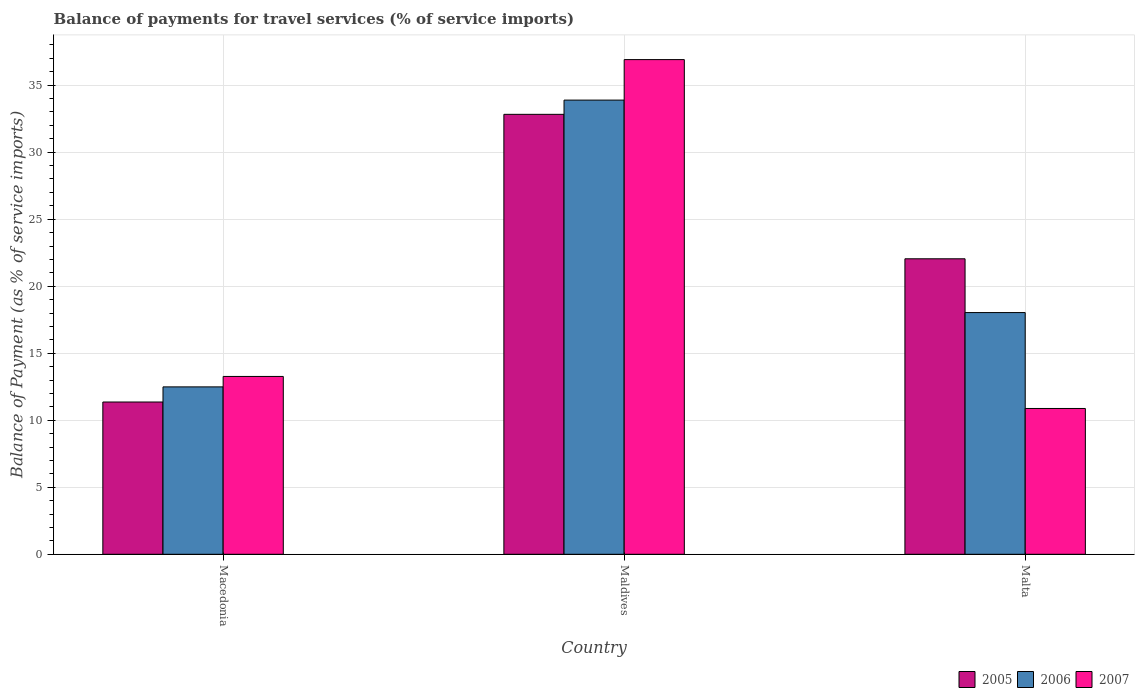How many different coloured bars are there?
Offer a very short reply. 3. How many bars are there on the 3rd tick from the right?
Make the answer very short. 3. What is the label of the 3rd group of bars from the left?
Offer a terse response. Malta. In how many cases, is the number of bars for a given country not equal to the number of legend labels?
Keep it short and to the point. 0. What is the balance of payments for travel services in 2007 in Maldives?
Offer a terse response. 36.91. Across all countries, what is the maximum balance of payments for travel services in 2005?
Ensure brevity in your answer.  32.82. Across all countries, what is the minimum balance of payments for travel services in 2005?
Your response must be concise. 11.36. In which country was the balance of payments for travel services in 2005 maximum?
Make the answer very short. Maldives. In which country was the balance of payments for travel services in 2005 minimum?
Ensure brevity in your answer.  Macedonia. What is the total balance of payments for travel services in 2006 in the graph?
Your response must be concise. 64.41. What is the difference between the balance of payments for travel services in 2005 in Macedonia and that in Malta?
Ensure brevity in your answer.  -10.68. What is the difference between the balance of payments for travel services in 2005 in Macedonia and the balance of payments for travel services in 2007 in Maldives?
Keep it short and to the point. -25.55. What is the average balance of payments for travel services in 2005 per country?
Your response must be concise. 22.08. What is the difference between the balance of payments for travel services of/in 2007 and balance of payments for travel services of/in 2006 in Malta?
Provide a short and direct response. -7.16. What is the ratio of the balance of payments for travel services in 2005 in Macedonia to that in Malta?
Offer a terse response. 0.52. Is the difference between the balance of payments for travel services in 2007 in Macedonia and Maldives greater than the difference between the balance of payments for travel services in 2006 in Macedonia and Maldives?
Keep it short and to the point. No. What is the difference between the highest and the second highest balance of payments for travel services in 2006?
Give a very brief answer. 15.85. What is the difference between the highest and the lowest balance of payments for travel services in 2006?
Offer a terse response. 21.4. In how many countries, is the balance of payments for travel services in 2006 greater than the average balance of payments for travel services in 2006 taken over all countries?
Keep it short and to the point. 1. Is it the case that in every country, the sum of the balance of payments for travel services in 2005 and balance of payments for travel services in 2007 is greater than the balance of payments for travel services in 2006?
Your answer should be compact. Yes. How many bars are there?
Keep it short and to the point. 9. How many countries are there in the graph?
Provide a succinct answer. 3. Are the values on the major ticks of Y-axis written in scientific E-notation?
Offer a terse response. No. What is the title of the graph?
Ensure brevity in your answer.  Balance of payments for travel services (% of service imports). Does "2011" appear as one of the legend labels in the graph?
Provide a succinct answer. No. What is the label or title of the Y-axis?
Your answer should be very brief. Balance of Payment (as % of service imports). What is the Balance of Payment (as % of service imports) of 2005 in Macedonia?
Your answer should be very brief. 11.36. What is the Balance of Payment (as % of service imports) in 2006 in Macedonia?
Your response must be concise. 12.49. What is the Balance of Payment (as % of service imports) of 2007 in Macedonia?
Give a very brief answer. 13.27. What is the Balance of Payment (as % of service imports) in 2005 in Maldives?
Your response must be concise. 32.82. What is the Balance of Payment (as % of service imports) of 2006 in Maldives?
Provide a succinct answer. 33.89. What is the Balance of Payment (as % of service imports) of 2007 in Maldives?
Provide a succinct answer. 36.91. What is the Balance of Payment (as % of service imports) in 2005 in Malta?
Provide a succinct answer. 22.05. What is the Balance of Payment (as % of service imports) in 2006 in Malta?
Offer a terse response. 18.03. What is the Balance of Payment (as % of service imports) of 2007 in Malta?
Your answer should be very brief. 10.88. Across all countries, what is the maximum Balance of Payment (as % of service imports) of 2005?
Make the answer very short. 32.82. Across all countries, what is the maximum Balance of Payment (as % of service imports) in 2006?
Keep it short and to the point. 33.89. Across all countries, what is the maximum Balance of Payment (as % of service imports) of 2007?
Your response must be concise. 36.91. Across all countries, what is the minimum Balance of Payment (as % of service imports) of 2005?
Ensure brevity in your answer.  11.36. Across all countries, what is the minimum Balance of Payment (as % of service imports) of 2006?
Your answer should be very brief. 12.49. Across all countries, what is the minimum Balance of Payment (as % of service imports) of 2007?
Offer a terse response. 10.88. What is the total Balance of Payment (as % of service imports) of 2005 in the graph?
Provide a succinct answer. 66.23. What is the total Balance of Payment (as % of service imports) of 2006 in the graph?
Make the answer very short. 64.41. What is the total Balance of Payment (as % of service imports) of 2007 in the graph?
Keep it short and to the point. 61.05. What is the difference between the Balance of Payment (as % of service imports) in 2005 in Macedonia and that in Maldives?
Offer a terse response. -21.46. What is the difference between the Balance of Payment (as % of service imports) of 2006 in Macedonia and that in Maldives?
Keep it short and to the point. -21.4. What is the difference between the Balance of Payment (as % of service imports) of 2007 in Macedonia and that in Maldives?
Your answer should be compact. -23.64. What is the difference between the Balance of Payment (as % of service imports) in 2005 in Macedonia and that in Malta?
Ensure brevity in your answer.  -10.68. What is the difference between the Balance of Payment (as % of service imports) of 2006 in Macedonia and that in Malta?
Give a very brief answer. -5.54. What is the difference between the Balance of Payment (as % of service imports) of 2007 in Macedonia and that in Malta?
Offer a very short reply. 2.39. What is the difference between the Balance of Payment (as % of service imports) in 2005 in Maldives and that in Malta?
Offer a very short reply. 10.78. What is the difference between the Balance of Payment (as % of service imports) in 2006 in Maldives and that in Malta?
Your answer should be compact. 15.85. What is the difference between the Balance of Payment (as % of service imports) of 2007 in Maldives and that in Malta?
Your response must be concise. 26.03. What is the difference between the Balance of Payment (as % of service imports) in 2005 in Macedonia and the Balance of Payment (as % of service imports) in 2006 in Maldives?
Provide a succinct answer. -22.52. What is the difference between the Balance of Payment (as % of service imports) in 2005 in Macedonia and the Balance of Payment (as % of service imports) in 2007 in Maldives?
Give a very brief answer. -25.55. What is the difference between the Balance of Payment (as % of service imports) of 2006 in Macedonia and the Balance of Payment (as % of service imports) of 2007 in Maldives?
Keep it short and to the point. -24.42. What is the difference between the Balance of Payment (as % of service imports) in 2005 in Macedonia and the Balance of Payment (as % of service imports) in 2006 in Malta?
Your response must be concise. -6.67. What is the difference between the Balance of Payment (as % of service imports) of 2005 in Macedonia and the Balance of Payment (as % of service imports) of 2007 in Malta?
Ensure brevity in your answer.  0.48. What is the difference between the Balance of Payment (as % of service imports) in 2006 in Macedonia and the Balance of Payment (as % of service imports) in 2007 in Malta?
Keep it short and to the point. 1.61. What is the difference between the Balance of Payment (as % of service imports) of 2005 in Maldives and the Balance of Payment (as % of service imports) of 2006 in Malta?
Offer a very short reply. 14.79. What is the difference between the Balance of Payment (as % of service imports) in 2005 in Maldives and the Balance of Payment (as % of service imports) in 2007 in Malta?
Provide a succinct answer. 21.95. What is the difference between the Balance of Payment (as % of service imports) in 2006 in Maldives and the Balance of Payment (as % of service imports) in 2007 in Malta?
Provide a succinct answer. 23.01. What is the average Balance of Payment (as % of service imports) of 2005 per country?
Make the answer very short. 22.08. What is the average Balance of Payment (as % of service imports) in 2006 per country?
Give a very brief answer. 21.47. What is the average Balance of Payment (as % of service imports) in 2007 per country?
Provide a short and direct response. 20.35. What is the difference between the Balance of Payment (as % of service imports) in 2005 and Balance of Payment (as % of service imports) in 2006 in Macedonia?
Your answer should be compact. -1.13. What is the difference between the Balance of Payment (as % of service imports) in 2005 and Balance of Payment (as % of service imports) in 2007 in Macedonia?
Give a very brief answer. -1.91. What is the difference between the Balance of Payment (as % of service imports) of 2006 and Balance of Payment (as % of service imports) of 2007 in Macedonia?
Provide a short and direct response. -0.78. What is the difference between the Balance of Payment (as % of service imports) in 2005 and Balance of Payment (as % of service imports) in 2006 in Maldives?
Ensure brevity in your answer.  -1.06. What is the difference between the Balance of Payment (as % of service imports) in 2005 and Balance of Payment (as % of service imports) in 2007 in Maldives?
Keep it short and to the point. -4.08. What is the difference between the Balance of Payment (as % of service imports) of 2006 and Balance of Payment (as % of service imports) of 2007 in Maldives?
Your answer should be compact. -3.02. What is the difference between the Balance of Payment (as % of service imports) of 2005 and Balance of Payment (as % of service imports) of 2006 in Malta?
Provide a short and direct response. 4.01. What is the difference between the Balance of Payment (as % of service imports) in 2005 and Balance of Payment (as % of service imports) in 2007 in Malta?
Make the answer very short. 11.17. What is the difference between the Balance of Payment (as % of service imports) of 2006 and Balance of Payment (as % of service imports) of 2007 in Malta?
Offer a terse response. 7.16. What is the ratio of the Balance of Payment (as % of service imports) of 2005 in Macedonia to that in Maldives?
Ensure brevity in your answer.  0.35. What is the ratio of the Balance of Payment (as % of service imports) in 2006 in Macedonia to that in Maldives?
Offer a very short reply. 0.37. What is the ratio of the Balance of Payment (as % of service imports) in 2007 in Macedonia to that in Maldives?
Make the answer very short. 0.36. What is the ratio of the Balance of Payment (as % of service imports) of 2005 in Macedonia to that in Malta?
Offer a very short reply. 0.52. What is the ratio of the Balance of Payment (as % of service imports) of 2006 in Macedonia to that in Malta?
Give a very brief answer. 0.69. What is the ratio of the Balance of Payment (as % of service imports) of 2007 in Macedonia to that in Malta?
Your answer should be compact. 1.22. What is the ratio of the Balance of Payment (as % of service imports) in 2005 in Maldives to that in Malta?
Give a very brief answer. 1.49. What is the ratio of the Balance of Payment (as % of service imports) of 2006 in Maldives to that in Malta?
Provide a succinct answer. 1.88. What is the ratio of the Balance of Payment (as % of service imports) in 2007 in Maldives to that in Malta?
Keep it short and to the point. 3.39. What is the difference between the highest and the second highest Balance of Payment (as % of service imports) of 2005?
Offer a very short reply. 10.78. What is the difference between the highest and the second highest Balance of Payment (as % of service imports) of 2006?
Keep it short and to the point. 15.85. What is the difference between the highest and the second highest Balance of Payment (as % of service imports) of 2007?
Ensure brevity in your answer.  23.64. What is the difference between the highest and the lowest Balance of Payment (as % of service imports) in 2005?
Your answer should be very brief. 21.46. What is the difference between the highest and the lowest Balance of Payment (as % of service imports) in 2006?
Provide a succinct answer. 21.4. What is the difference between the highest and the lowest Balance of Payment (as % of service imports) in 2007?
Ensure brevity in your answer.  26.03. 